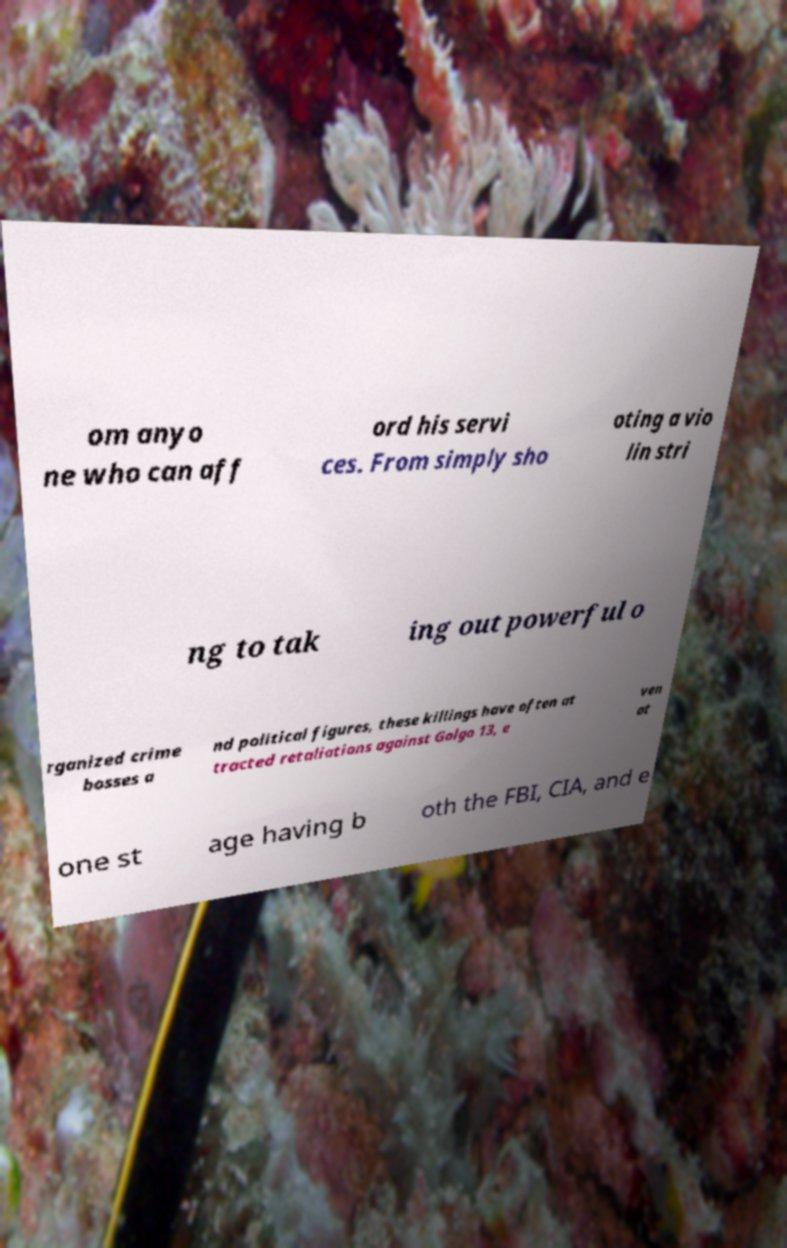Could you extract and type out the text from this image? om anyo ne who can aff ord his servi ces. From simply sho oting a vio lin stri ng to tak ing out powerful o rganized crime bosses a nd political figures, these killings have often at tracted retaliations against Golgo 13, e ven at one st age having b oth the FBI, CIA, and e 